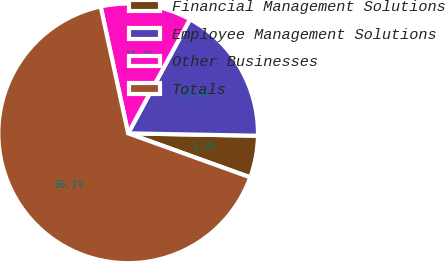<chart> <loc_0><loc_0><loc_500><loc_500><pie_chart><fcel>Financial Management Solutions<fcel>Employee Management Solutions<fcel>Other Businesses<fcel>Totals<nl><fcel>5.21%<fcel>17.39%<fcel>11.3%<fcel>66.09%<nl></chart> 